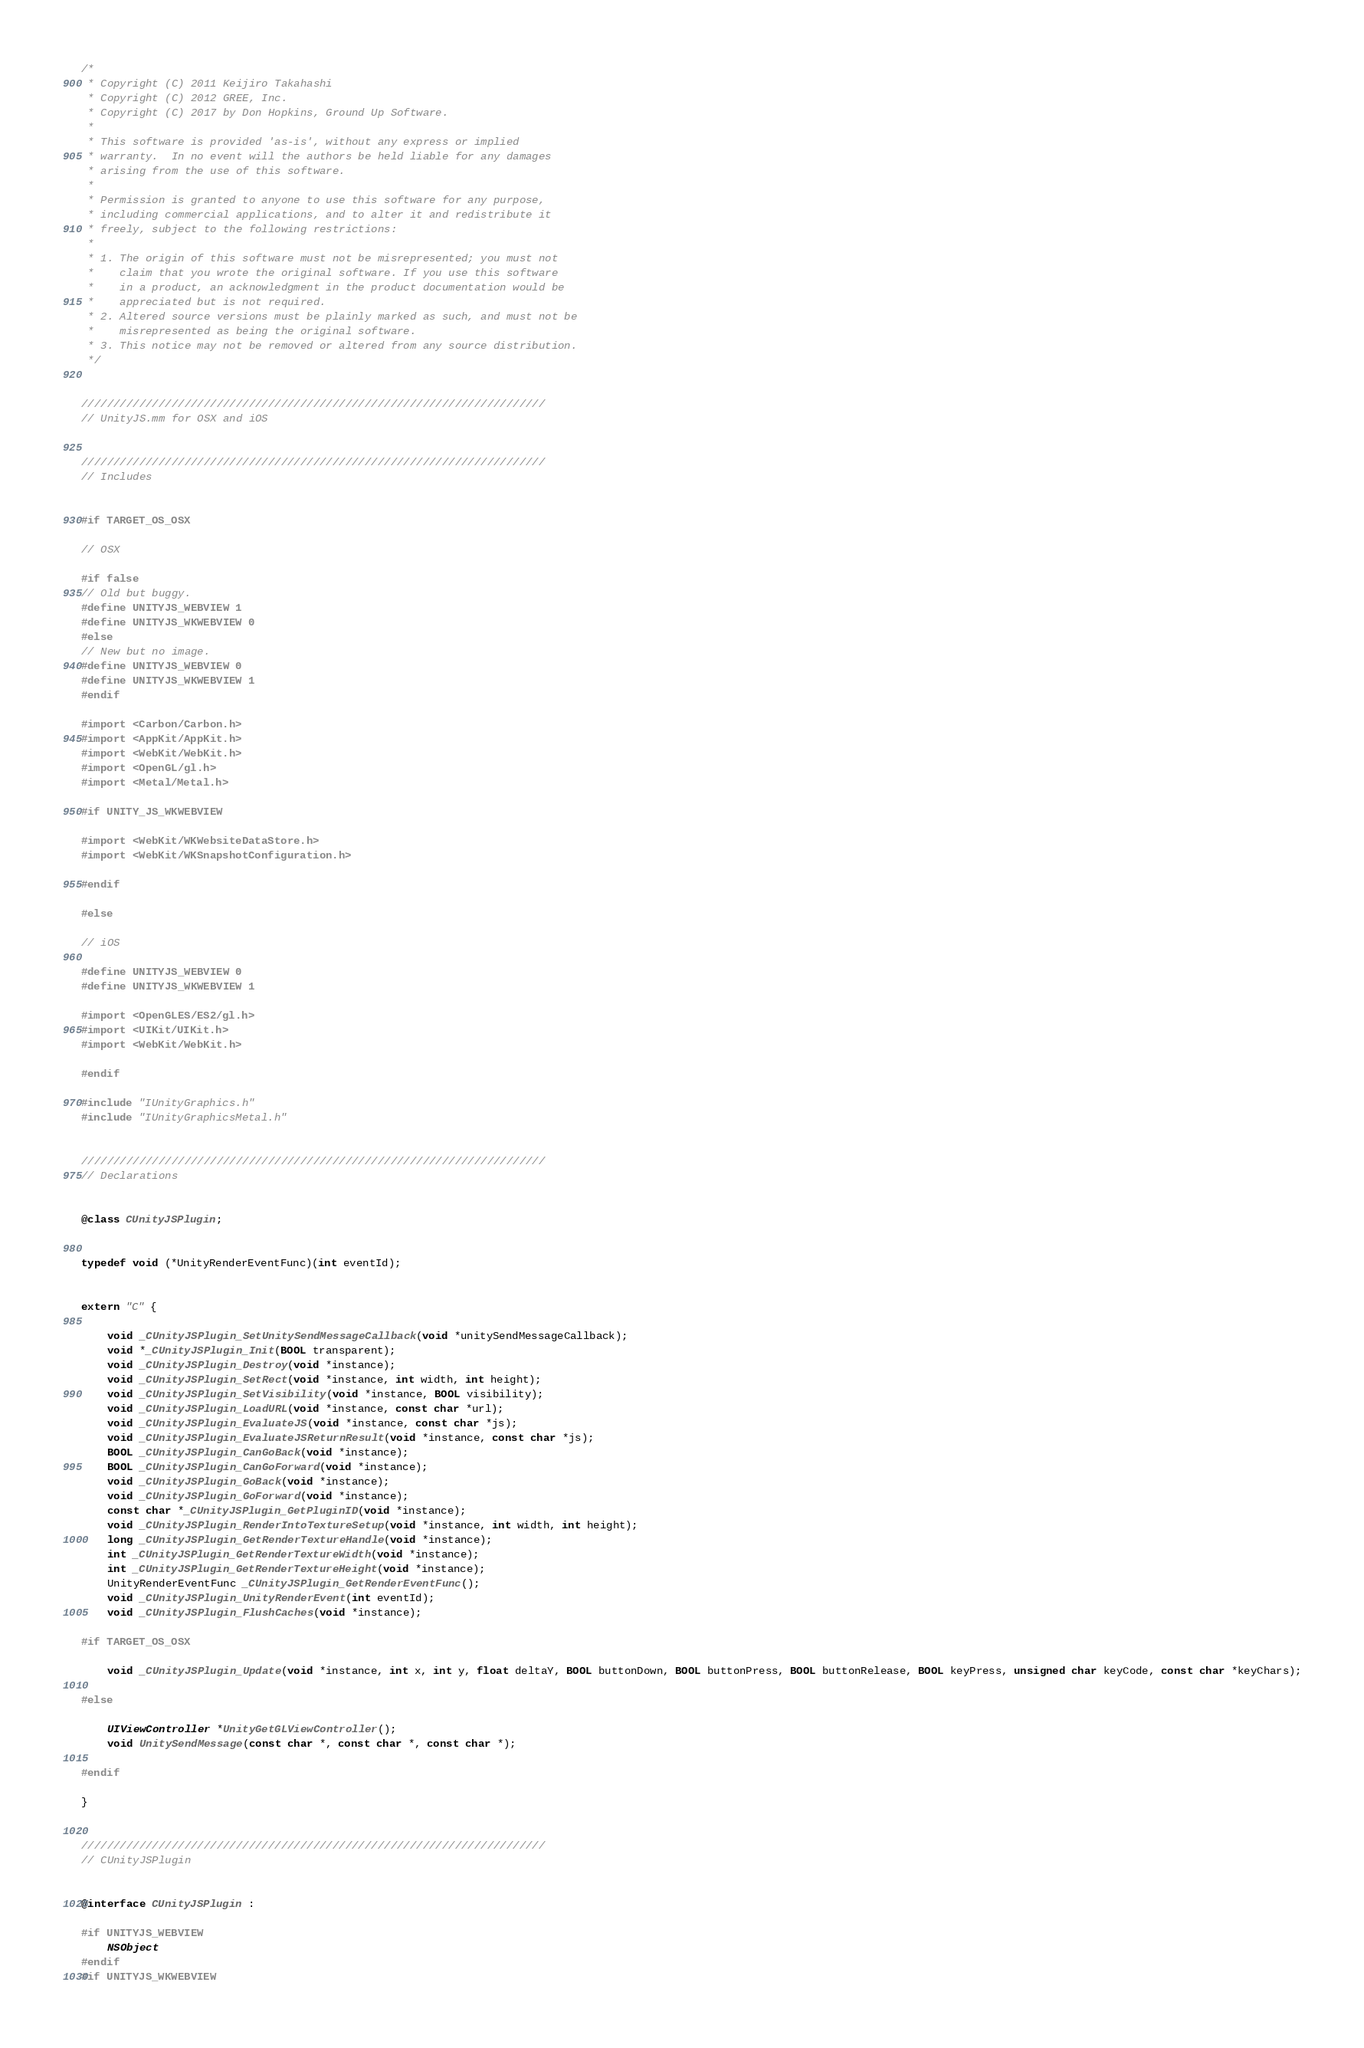<code> <loc_0><loc_0><loc_500><loc_500><_ObjectiveC_>/*
 * Copyright (C) 2011 Keijiro Takahashi
 * Copyright (C) 2012 GREE, Inc.
 * Copyright (C) 2017 by Don Hopkins, Ground Up Software.
 *
 * This software is provided 'as-is', without any express or implied
 * warranty.  In no event will the authors be held liable for any damages
 * arising from the use of this software.
 *
 * Permission is granted to anyone to use this software for any purpose,
 * including commercial applications, and to alter it and redistribute it
 * freely, subject to the following restrictions:
 *
 * 1. The origin of this software must not be misrepresented; you must not
 *    claim that you wrote the original software. If you use this software
 *    in a product, an acknowledgment in the product documentation would be
 *    appreciated but is not required.
 * 2. Altered source versions must be plainly marked as such, and must not be
 *    misrepresented as being the original software.
 * 3. This notice may not be removed or altered from any source distribution.
 */


////////////////////////////////////////////////////////////////////////
// UnityJS.mm for OSX and iOS


////////////////////////////////////////////////////////////////////////
// Includes


#if TARGET_OS_OSX

// OSX

#if false
// Old but buggy.
#define UNITYJS_WEBVIEW 1
#define UNITYJS_WKWEBVIEW 0
#else
// New but no image.
#define UNITYJS_WEBVIEW 0
#define UNITYJS_WKWEBVIEW 1
#endif

#import <Carbon/Carbon.h>
#import <AppKit/AppKit.h>
#import <WebKit/WebKit.h>
#import <OpenGL/gl.h>
#import <Metal/Metal.h>

#if UNITY_JS_WKWEBVIEW

#import <WebKit/WKWebsiteDataStore.h>
#import <WebKit/WKSnapshotConfiguration.h>

#endif

#else

// iOS

#define UNITYJS_WEBVIEW 0
#define UNITYJS_WKWEBVIEW 1

#import <OpenGLES/ES2/gl.h>
#import <UIKit/UIKit.h>
#import <WebKit/WebKit.h>

#endif

#include "IUnityGraphics.h"
#include "IUnityGraphicsMetal.h"


////////////////////////////////////////////////////////////////////////
// Declarations


@class CUnityJSPlugin;


typedef void (*UnityRenderEventFunc)(int eventId);


extern "C" {

    void _CUnityJSPlugin_SetUnitySendMessageCallback(void *unitySendMessageCallback);
    void *_CUnityJSPlugin_Init(BOOL transparent);
    void _CUnityJSPlugin_Destroy(void *instance);
    void _CUnityJSPlugin_SetRect(void *instance, int width, int height);
    void _CUnityJSPlugin_SetVisibility(void *instance, BOOL visibility);
    void _CUnityJSPlugin_LoadURL(void *instance, const char *url);
    void _CUnityJSPlugin_EvaluateJS(void *instance, const char *js);
    void _CUnityJSPlugin_EvaluateJSReturnResult(void *instance, const char *js);
    BOOL _CUnityJSPlugin_CanGoBack(void *instance);
    BOOL _CUnityJSPlugin_CanGoForward(void *instance);
    void _CUnityJSPlugin_GoBack(void *instance);
    void _CUnityJSPlugin_GoForward(void *instance);
    const char *_CUnityJSPlugin_GetPluginID(void *instance);
    void _CUnityJSPlugin_RenderIntoTextureSetup(void *instance, int width, int height);
    long _CUnityJSPlugin_GetRenderTextureHandle(void *instance);
    int _CUnityJSPlugin_GetRenderTextureWidth(void *instance);
    int _CUnityJSPlugin_GetRenderTextureHeight(void *instance);
    UnityRenderEventFunc _CUnityJSPlugin_GetRenderEventFunc();
    void _CUnityJSPlugin_UnityRenderEvent(int eventId);
    void _CUnityJSPlugin_FlushCaches(void *instance);

#if TARGET_OS_OSX

    void _CUnityJSPlugin_Update(void *instance, int x, int y, float deltaY, BOOL buttonDown, BOOL buttonPress, BOOL buttonRelease, BOOL keyPress, unsigned char keyCode, const char *keyChars);

#else

    UIViewController *UnityGetGLViewController();
    void UnitySendMessage(const char *, const char *, const char *);

#endif

}


////////////////////////////////////////////////////////////////////////
// CUnityJSPlugin


@interface CUnityJSPlugin :

#if UNITYJS_WEBVIEW
    NSObject
#endif
#if UNITYJS_WKWEBVIEW</code> 